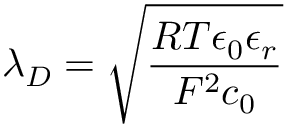<formula> <loc_0><loc_0><loc_500><loc_500>\lambda _ { D } = \sqrt { \frac { R T \epsilon _ { 0 } \epsilon _ { r } } { F ^ { 2 } c _ { 0 } } }</formula> 